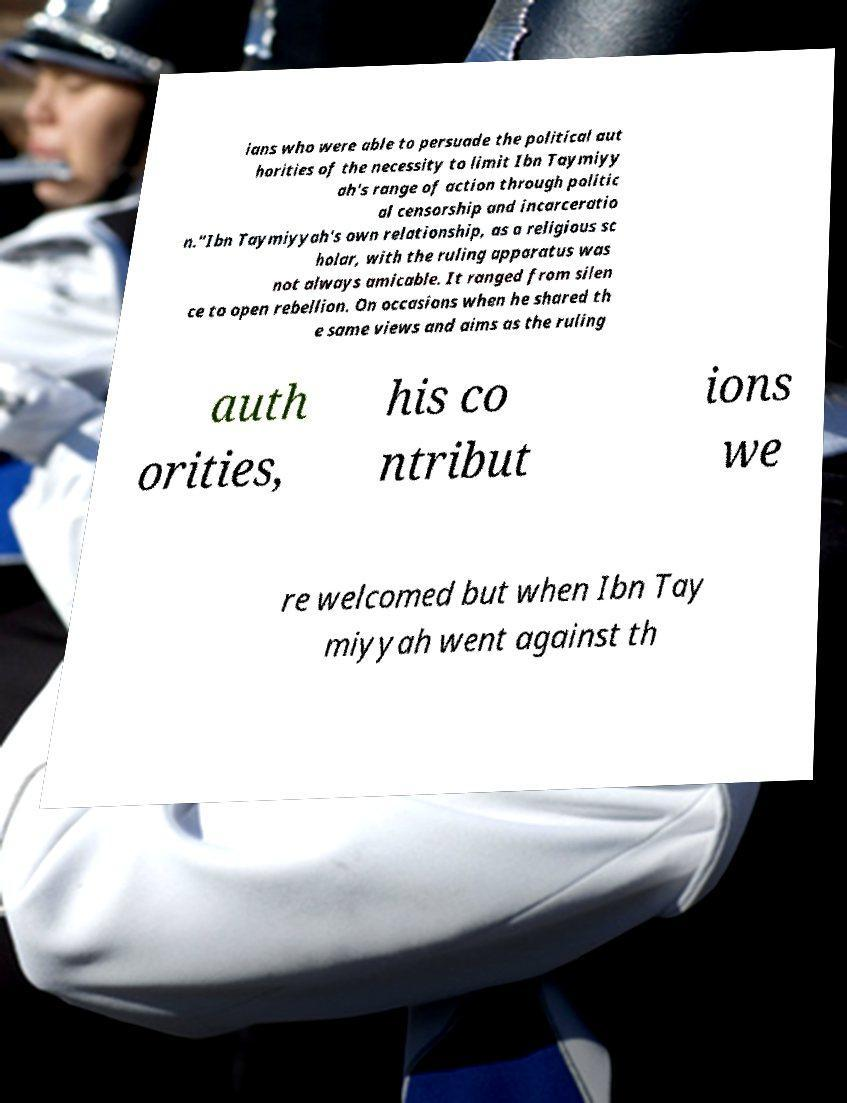Can you read and provide the text displayed in the image?This photo seems to have some interesting text. Can you extract and type it out for me? ians who were able to persuade the political aut horities of the necessity to limit Ibn Taymiyy ah's range of action through politic al censorship and incarceratio n."Ibn Taymiyyah's own relationship, as a religious sc holar, with the ruling apparatus was not always amicable. It ranged from silen ce to open rebellion. On occasions when he shared th e same views and aims as the ruling auth orities, his co ntribut ions we re welcomed but when Ibn Tay miyyah went against th 